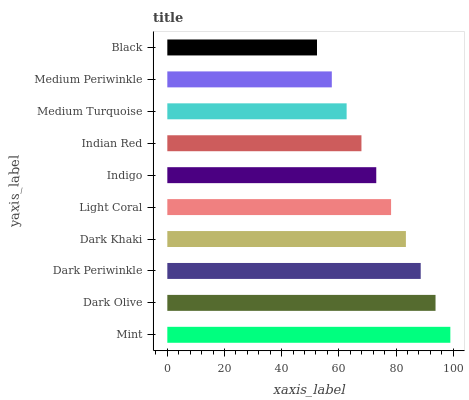Is Black the minimum?
Answer yes or no. Yes. Is Mint the maximum?
Answer yes or no. Yes. Is Dark Olive the minimum?
Answer yes or no. No. Is Dark Olive the maximum?
Answer yes or no. No. Is Mint greater than Dark Olive?
Answer yes or no. Yes. Is Dark Olive less than Mint?
Answer yes or no. Yes. Is Dark Olive greater than Mint?
Answer yes or no. No. Is Mint less than Dark Olive?
Answer yes or no. No. Is Light Coral the high median?
Answer yes or no. Yes. Is Indigo the low median?
Answer yes or no. Yes. Is Indian Red the high median?
Answer yes or no. No. Is Black the low median?
Answer yes or no. No. 